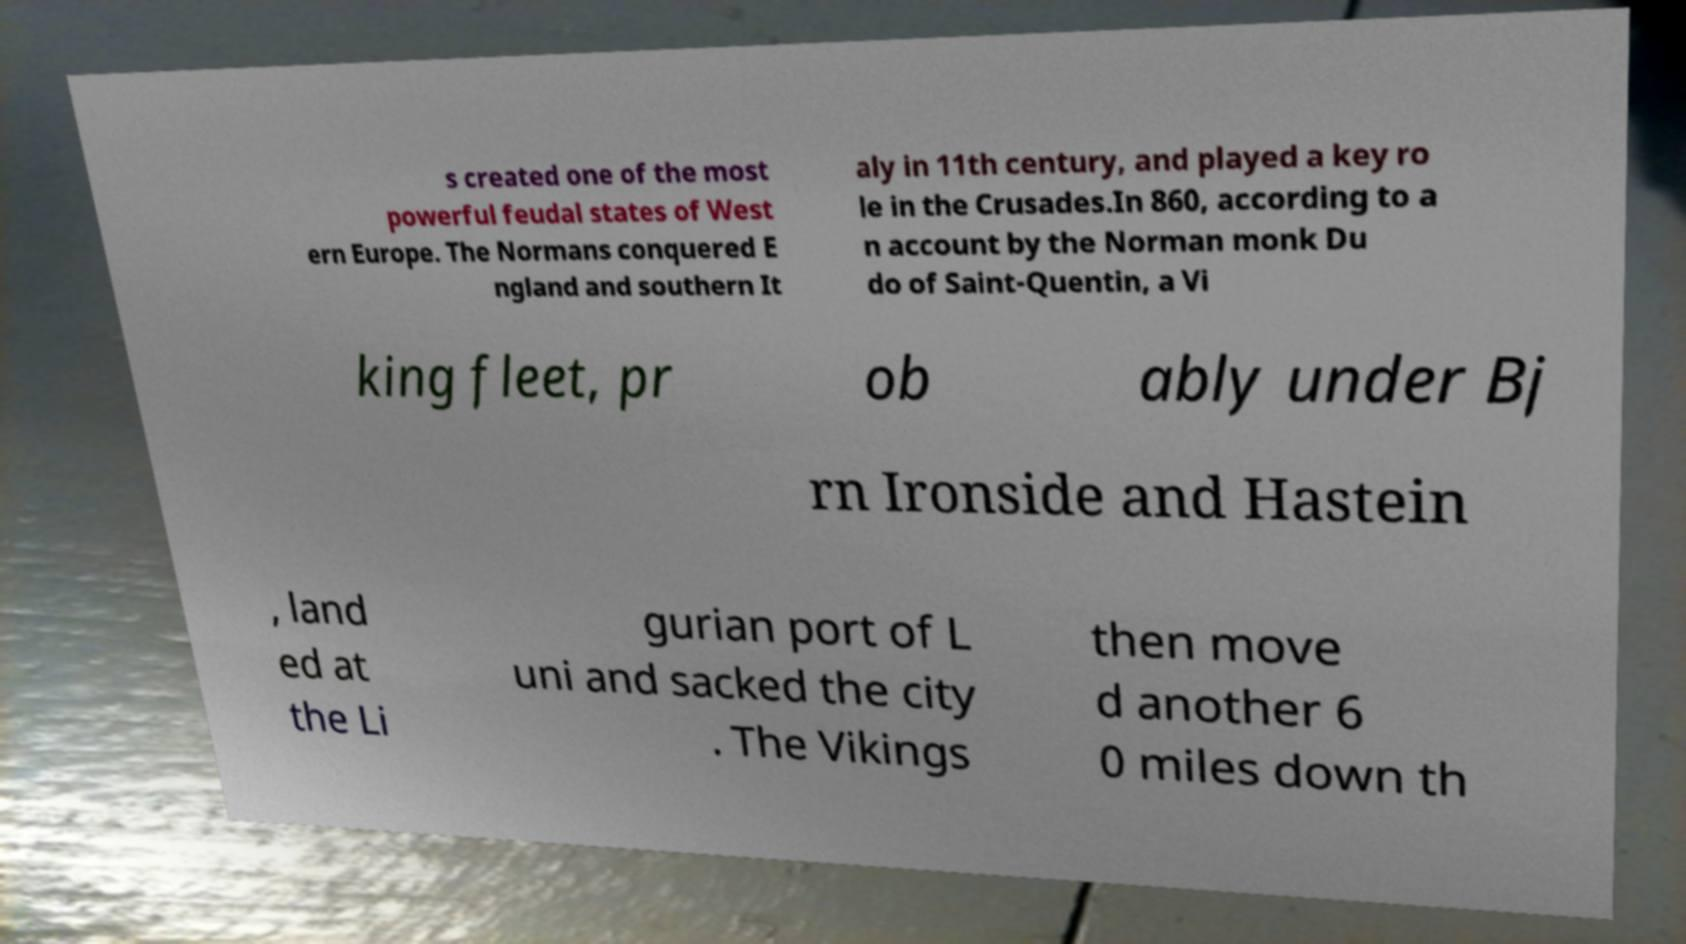Can you accurately transcribe the text from the provided image for me? s created one of the most powerful feudal states of West ern Europe. The Normans conquered E ngland and southern It aly in 11th century, and played a key ro le in the Crusades.In 860, according to a n account by the Norman monk Du do of Saint-Quentin, a Vi king fleet, pr ob ably under Bj rn Ironside and Hastein , land ed at the Li gurian port of L uni and sacked the city . The Vikings then move d another 6 0 miles down th 